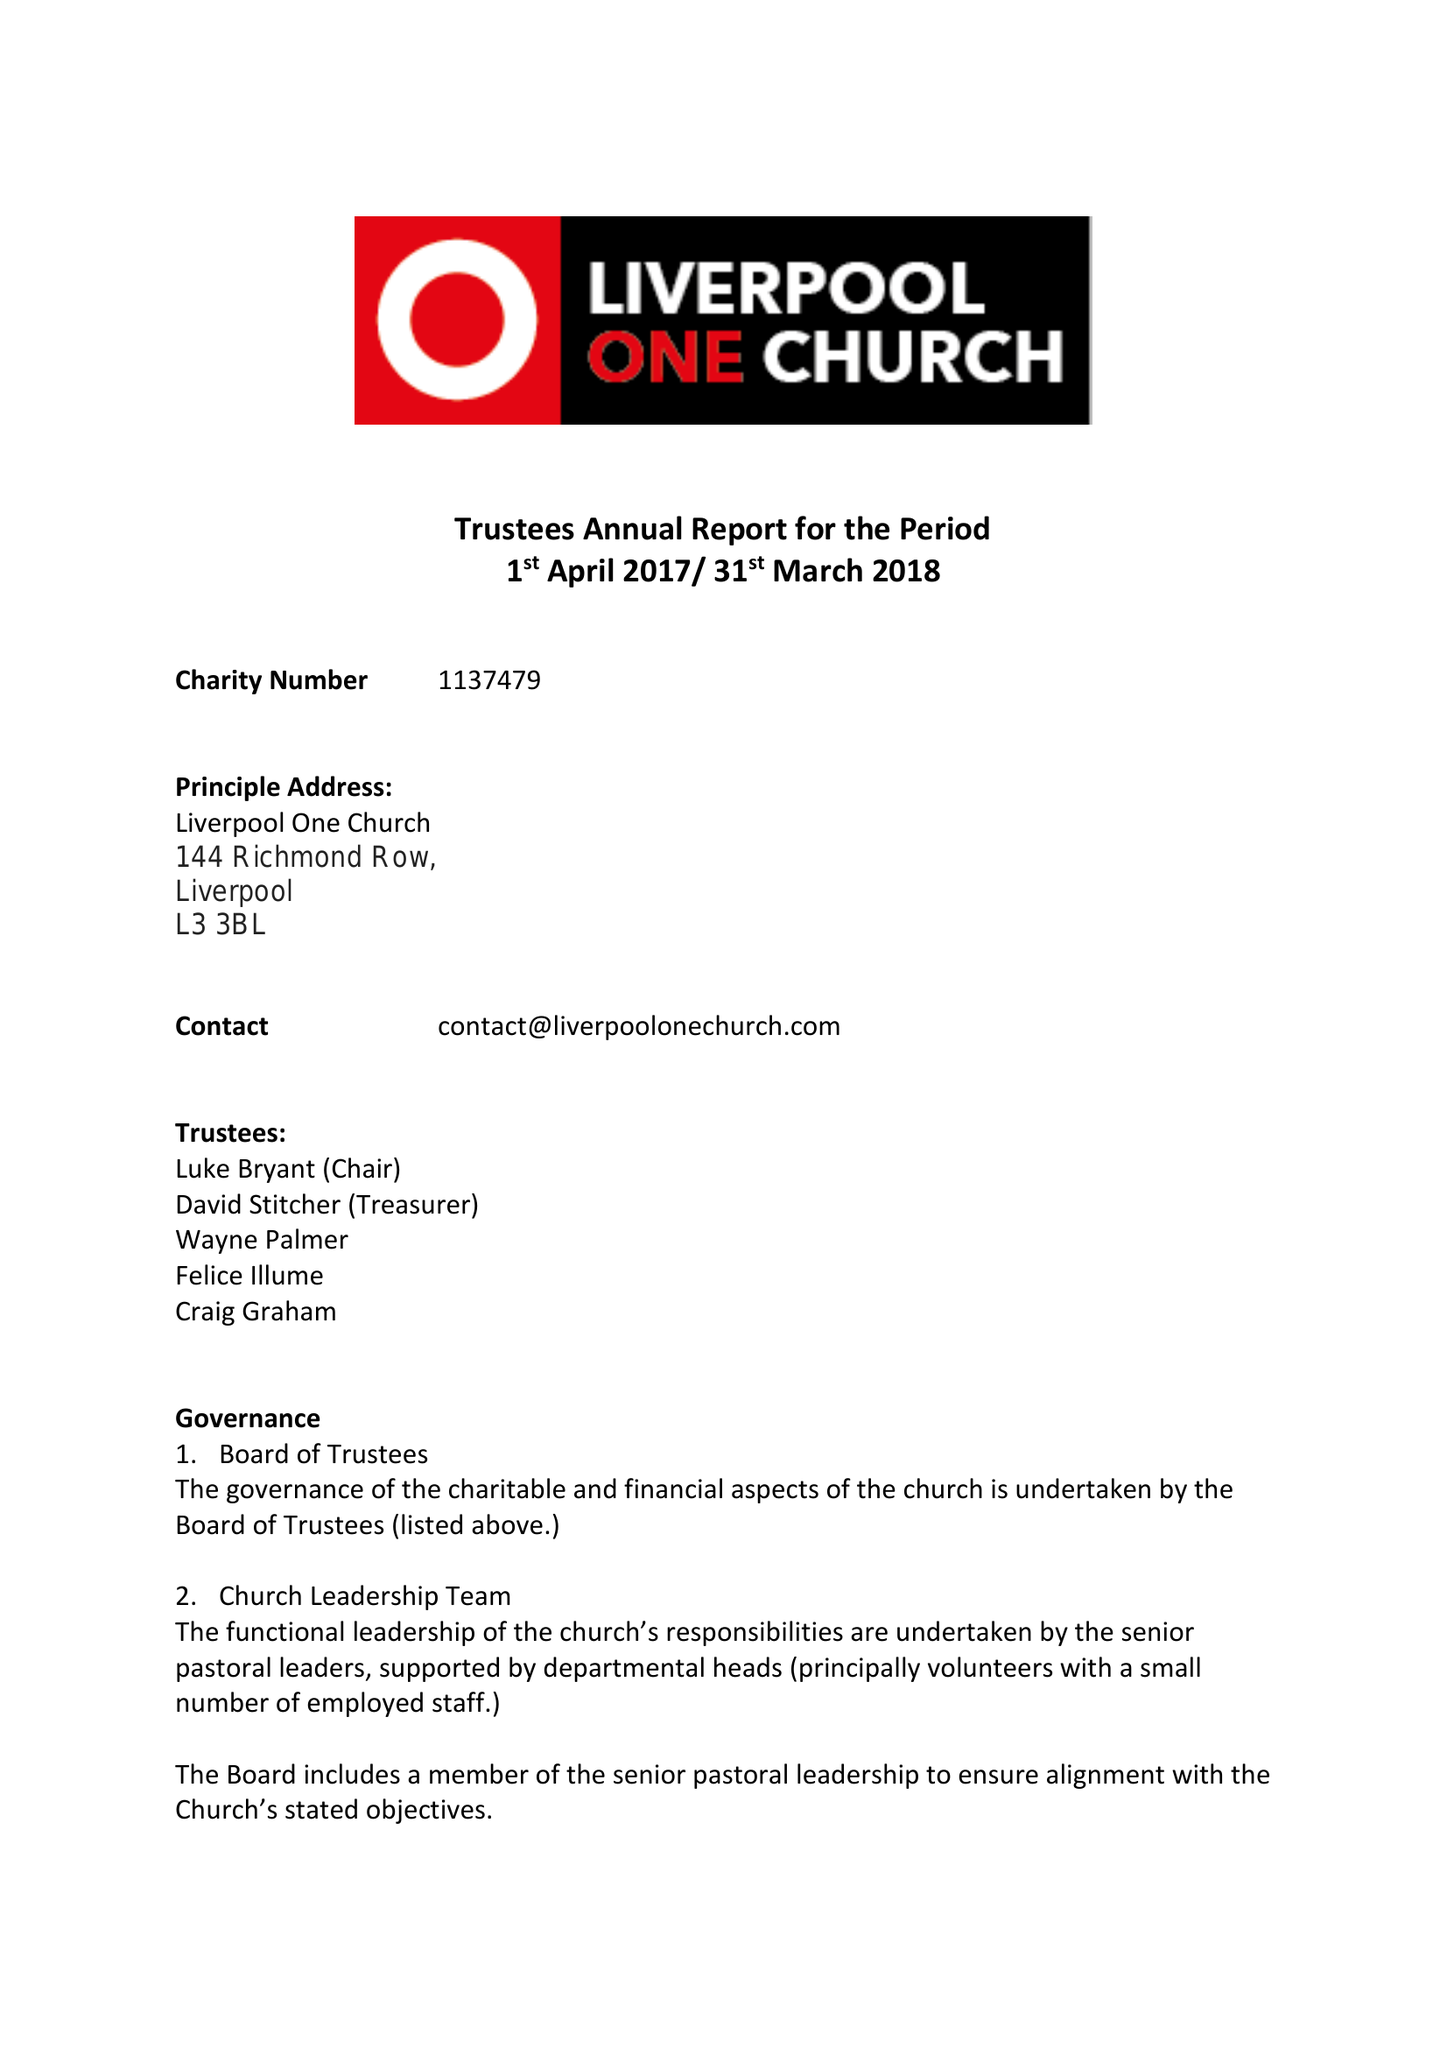What is the value for the spending_annually_in_british_pounds?
Answer the question using a single word or phrase. 182686.00 